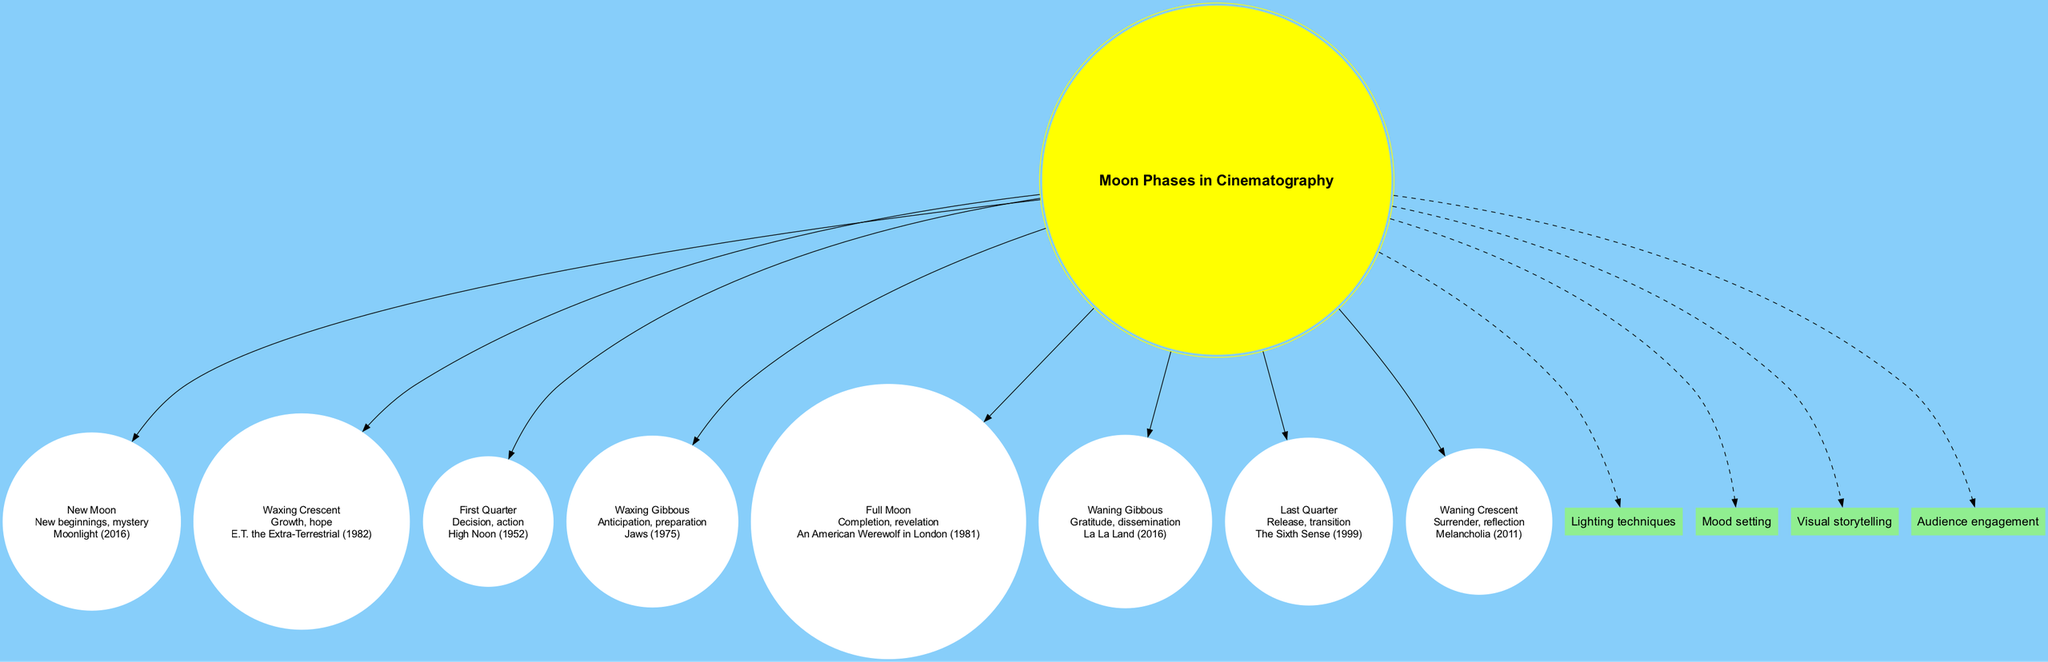What is the symbolism associated with the Full Moon? The diagram indicates that the Full Moon symbolizes "Completion, revelation." I can find this information in the Full Moon node, where it's clearly noted.
Answer: Completion, revelation Which film is associated with the Waning Gibbous phase? Referring to the Waning Gibbous node, I see that it is linked to the film "La La Land (2016)." Thus, the answer comes directly from that specific node.
Answer: La La Land (2016) How many moon phases are represented in the diagram? The diagram includes a total of eight moon phase nodes stemming from the center node. I count each phase listed to come to this total.
Answer: 8 What is the impact of lighting techniques on cinematography? The diagram states that lighting techniques are a direct influence of the center node, enhancing visuals. This information can be traced from the center to the specific impact node connected by a dashed edge.
Answer: Lighting techniques Which phase signifies growth and hope? Reviewing the nodes, I find that the Waxing Crescent phase represents "Growth, hope." This is clearly shown in that specific node's symbolism.
Answer: Growth, hope How does the First Quarter phase influence cinematography? The diagram indicates that the First Quarter phase embodies "Decision, action." This suggests its importance in visual storytelling, reflected through the specific impact on audience perception.
Answer: Decision, action What is the relationship between the Waxing Gibbous phase and Jaws? Jaws (1975) is connected to the Waxing Gibbous phase, which symbolizes "Anticipation, preparation." This relationship is established by identifying the film example listed under that moon phase.
Answer: Anticipation, preparation In what way does the Waning Crescent phase impact film storytelling? The Waning Crescent is characterized by its symbolism of "Surrender, reflection." This shows a significant impact on mood and visual storytelling as expressed in the cinematography section.
Answer: Surrender, reflection 